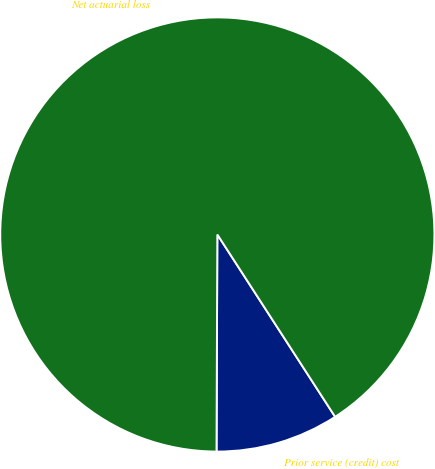Convert chart. <chart><loc_0><loc_0><loc_500><loc_500><pie_chart><fcel>Prior service (credit) cost<fcel>Net actuarial loss<nl><fcel>9.19%<fcel>90.81%<nl></chart> 